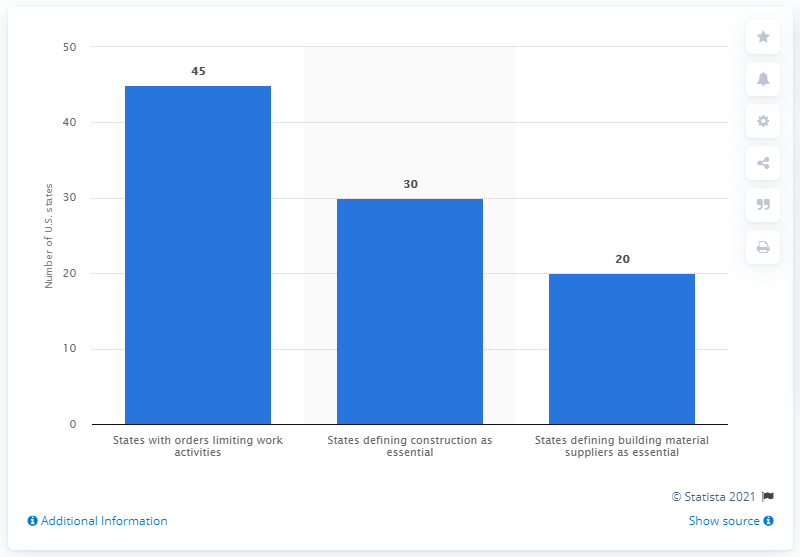Draw attention to some important aspects in this diagram. Forty-five states have enacted laws restricting certain work activities. Thirty states have recognized construction activities as critical to their economies and have designated them as essential. 